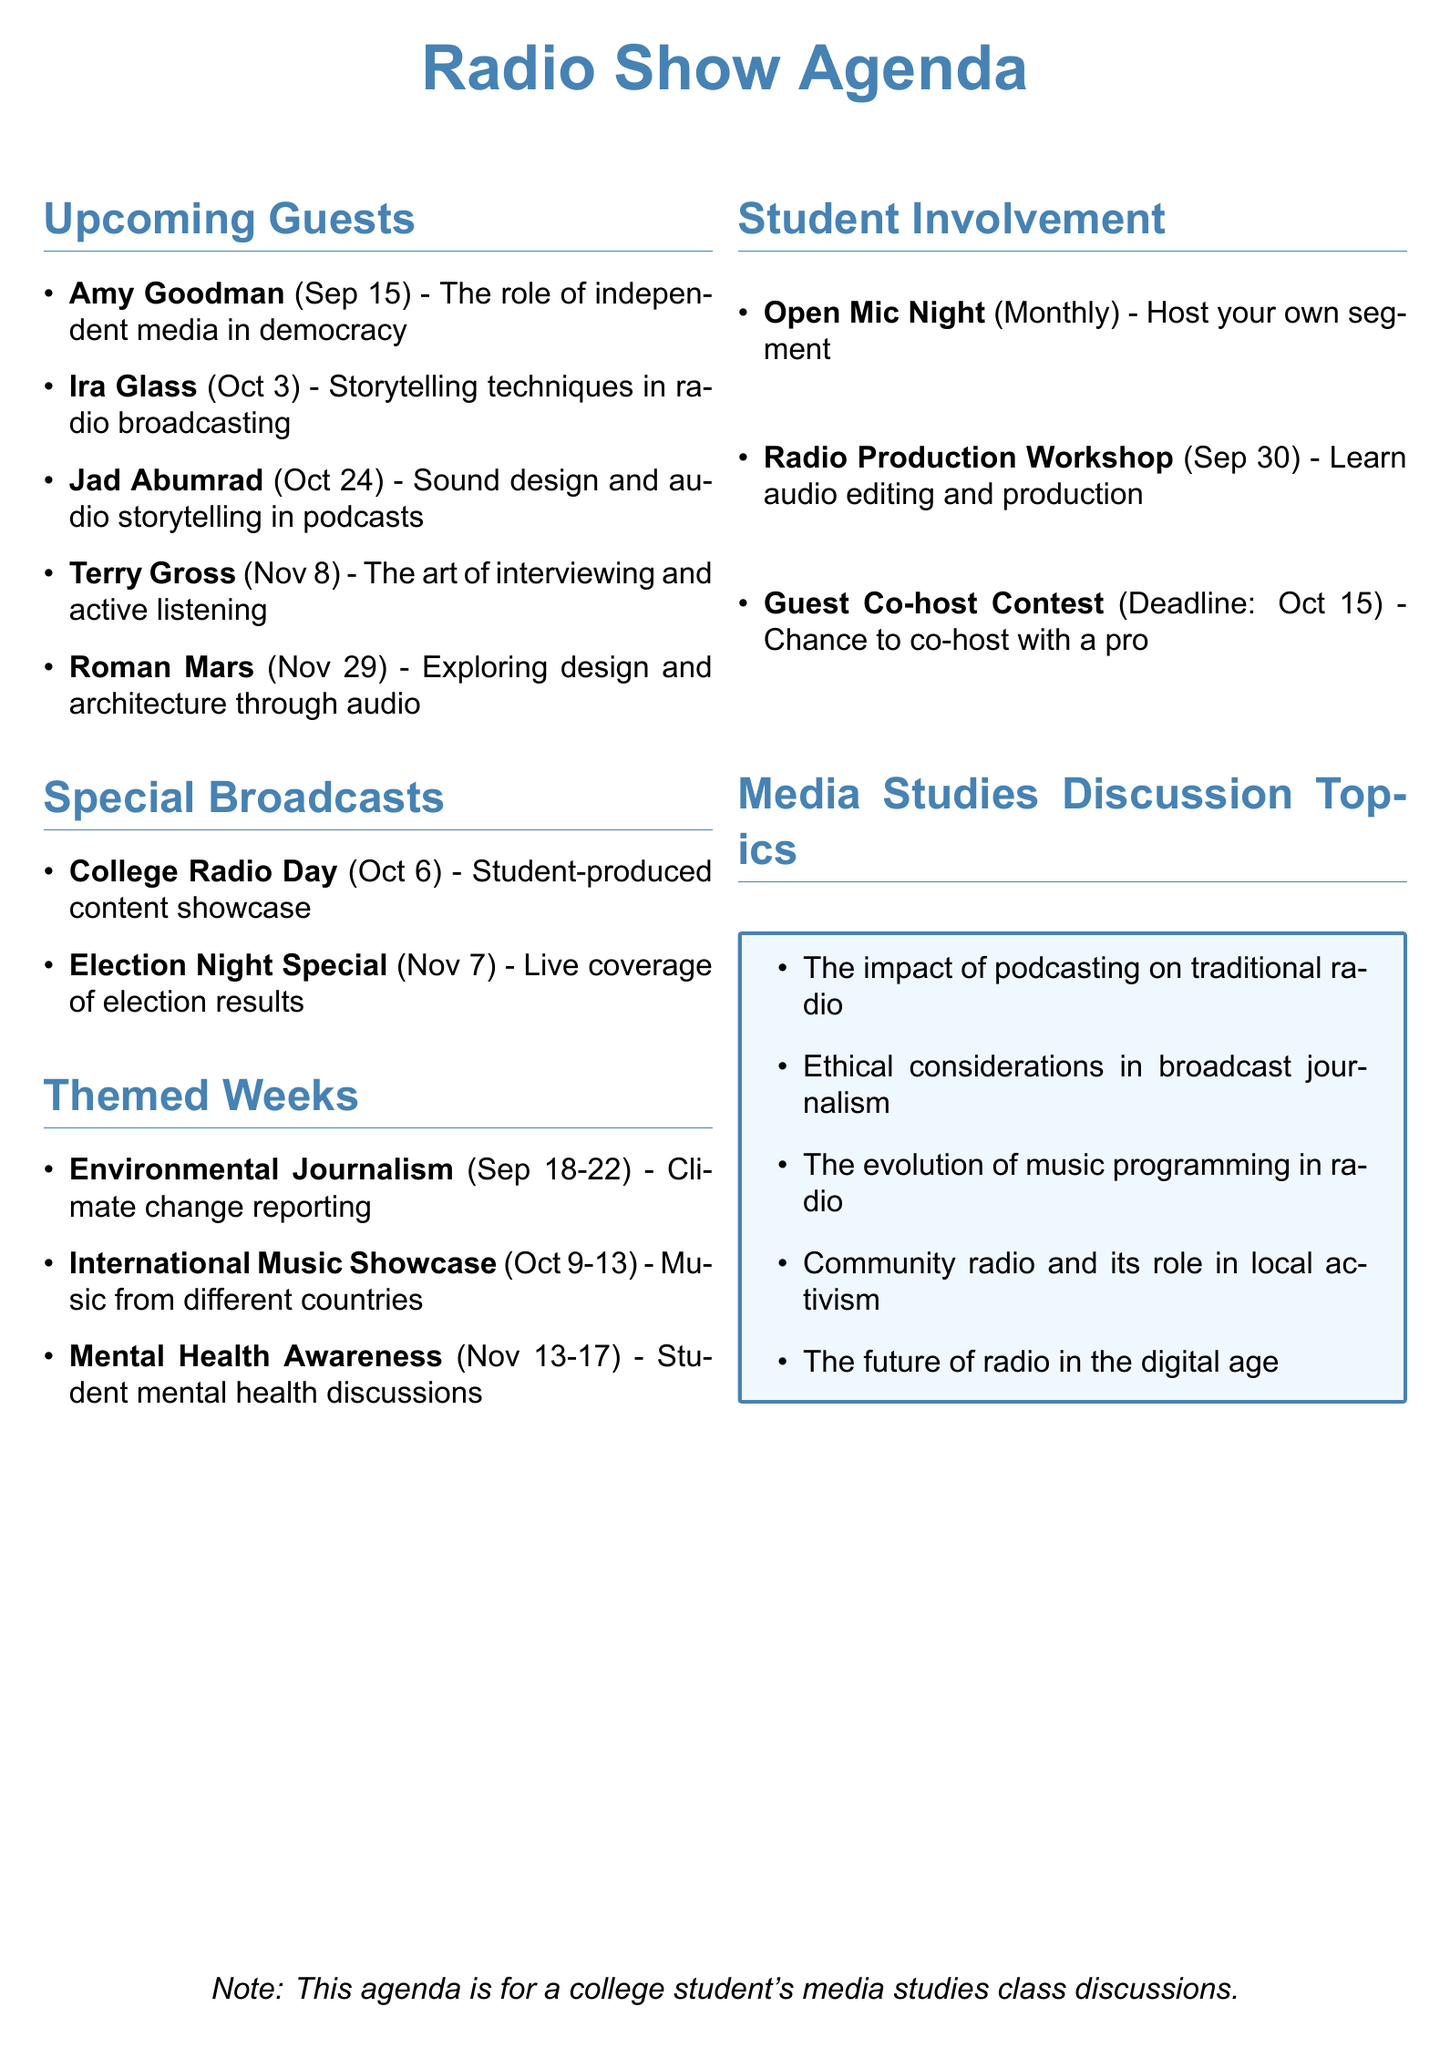What is the date of the interview with Amy Goodman? The specific date for Amy Goodman’s interview is explicitly mentioned in the document.
Answer: September 15, 2023 What is the theme of the interview with Terry Gross? The document states the interview theme for Terry Gross, which is noted alongside her name.
Answer: The art of interviewing and active listening Who is the host and producer of This American Life? This detail is provided in the section about upcoming guests where Ira Glass's role is described.
Answer: Ira Glass What week is dedicated to Mental Health Awareness? The document lists themed weeks with specific dates, including a focus on mental health.
Answer: November 13-17, 2023 What event is scheduled for October 6, 2023? The document specifies this date as part of the special broadcasts section with a particular event.
Answer: College Radio Day How often is Open Mic Night held? The document explicitly mentions the frequency of this event under student involvement opportunities.
Answer: Monthly Which guest is associated with sound design and audio storytelling? The document connects specific themes to each upcoming guest, allowing for easy identification.
Answer: Jad Abumrad What is the focus of the Environmental Journalism Week? The document lists each themed week along with its focus, particularly for this one.
Answer: Climate change reporting and sustainability initiatives on campus By what date must audition tapes be submitted for the Guest Co-host Contest? This is directly noted in the student involvement opportunities section of the document.
Answer: October 15, 2023 